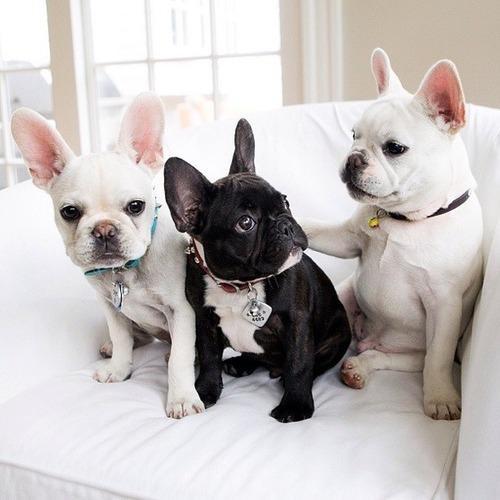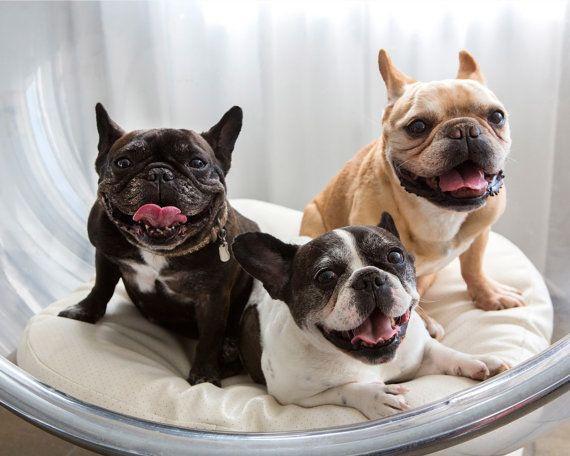The first image is the image on the left, the second image is the image on the right. For the images shown, is this caption "There are exactly three bulldogs in each image" true? Answer yes or no. Yes. The first image is the image on the left, the second image is the image on the right. For the images displayed, is the sentence "The right image contains exactly three bulldogs." factually correct? Answer yes or no. Yes. 